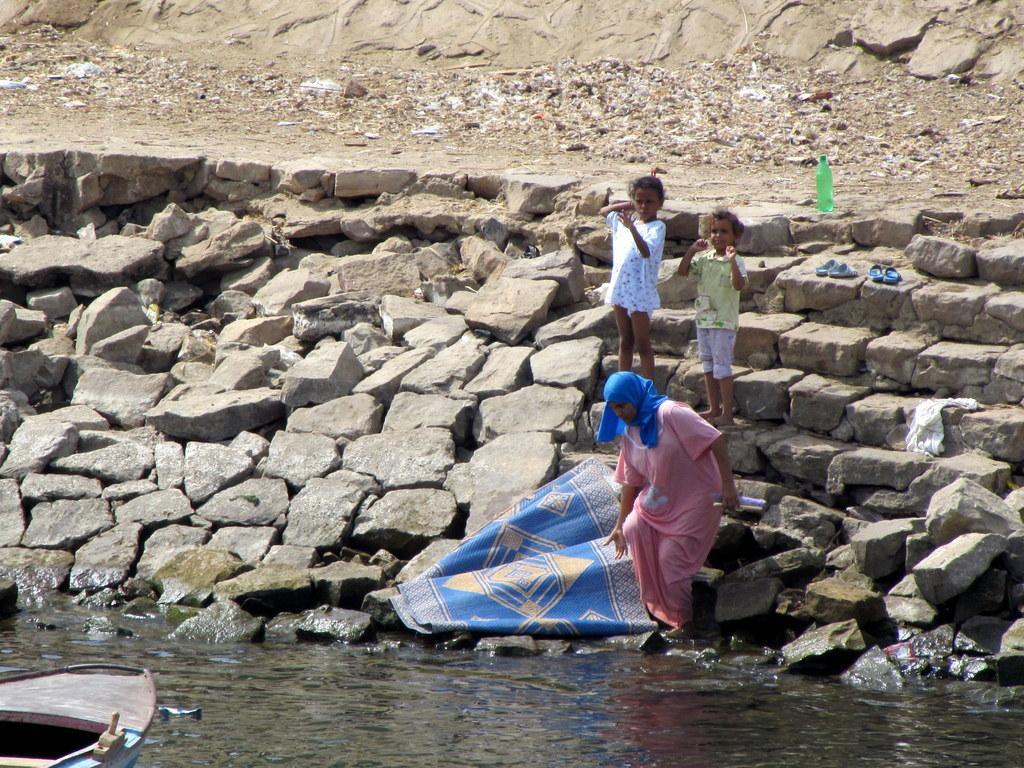Please provide a concise description of this image. In the given image i can see a stone's,people,bottle,slippers,mat,boat and water. 